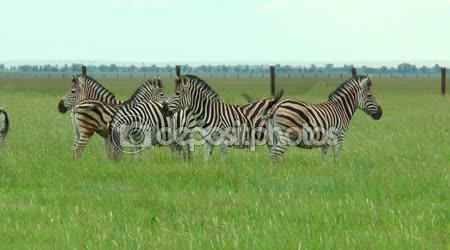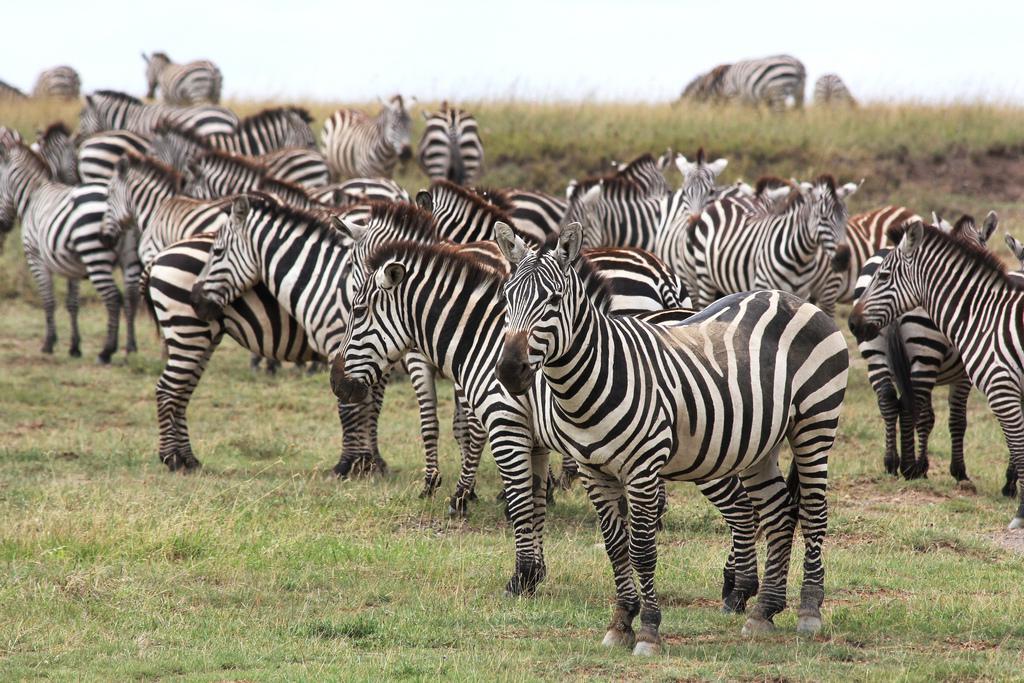The first image is the image on the left, the second image is the image on the right. Evaluate the accuracy of this statement regarding the images: "An image shows several zebras with their backs to the camera facing a group of at least five hooved animals belonging to one other species.". Is it true? Answer yes or no. No. The first image is the image on the left, the second image is the image on the right. Considering the images on both sides, is "IN at least one image there are at least 4 zebras facing away from the camera looking at a different breed of animal." valid? Answer yes or no. No. 